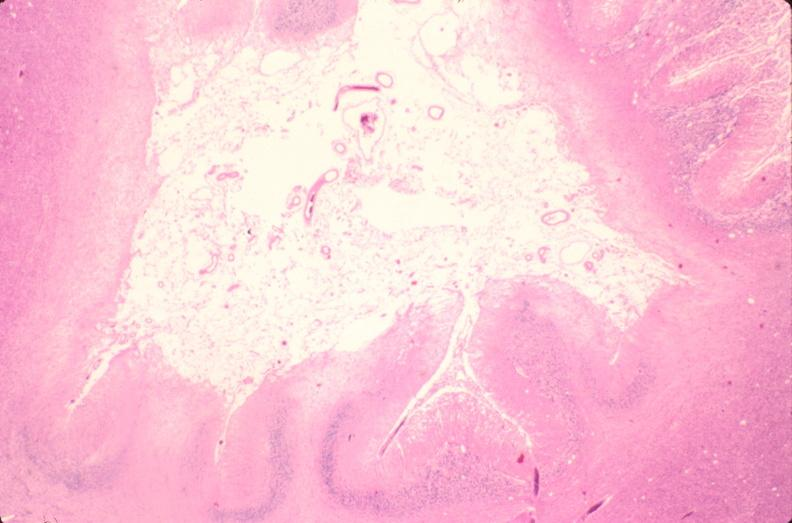where is this?
Answer the question using a single word or phrase. Nervous 